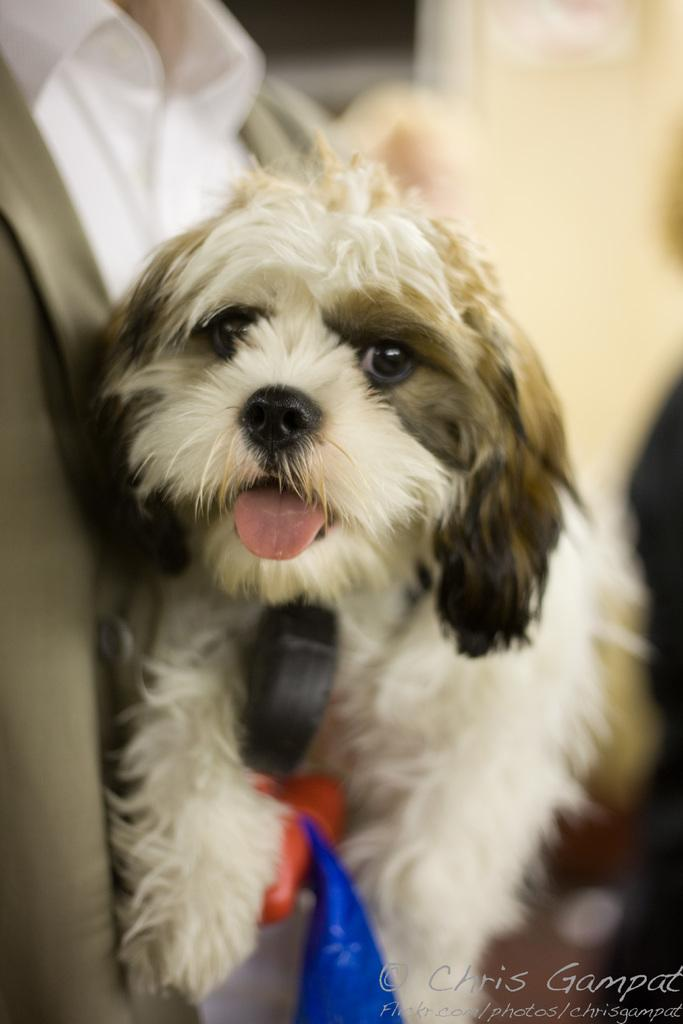Who or what is the main subject in the image? There is a person in the image. What is the person holding in the image? The person is holding a puppy. Is there any text present in the image? Yes, there is some text in the bottom right corner of the image. How would you describe the background of the image? The background of the image is blurred. How many bikes are visible in the image? There are no bikes visible in the image. What type of earth can be seen in the image? There is no earth present in the image; it is a person holding a puppy with a blurred background. 